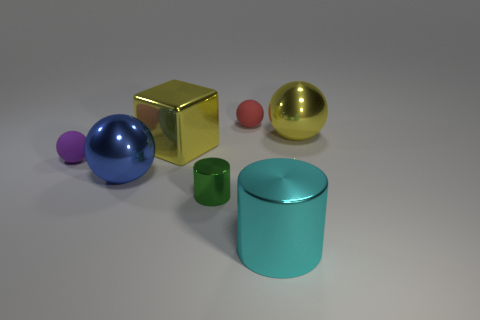Subtract all purple spheres. How many spheres are left? 3 Subtract all purple matte spheres. How many spheres are left? 3 Subtract all green spheres. Subtract all gray cylinders. How many spheres are left? 4 Add 3 yellow spheres. How many objects exist? 10 Subtract all cylinders. How many objects are left? 5 Add 7 big brown rubber cylinders. How many big brown rubber cylinders exist? 7 Subtract 1 blue spheres. How many objects are left? 6 Subtract all small gray metal cylinders. Subtract all metallic balls. How many objects are left? 5 Add 7 large yellow metal cubes. How many large yellow metal cubes are left? 8 